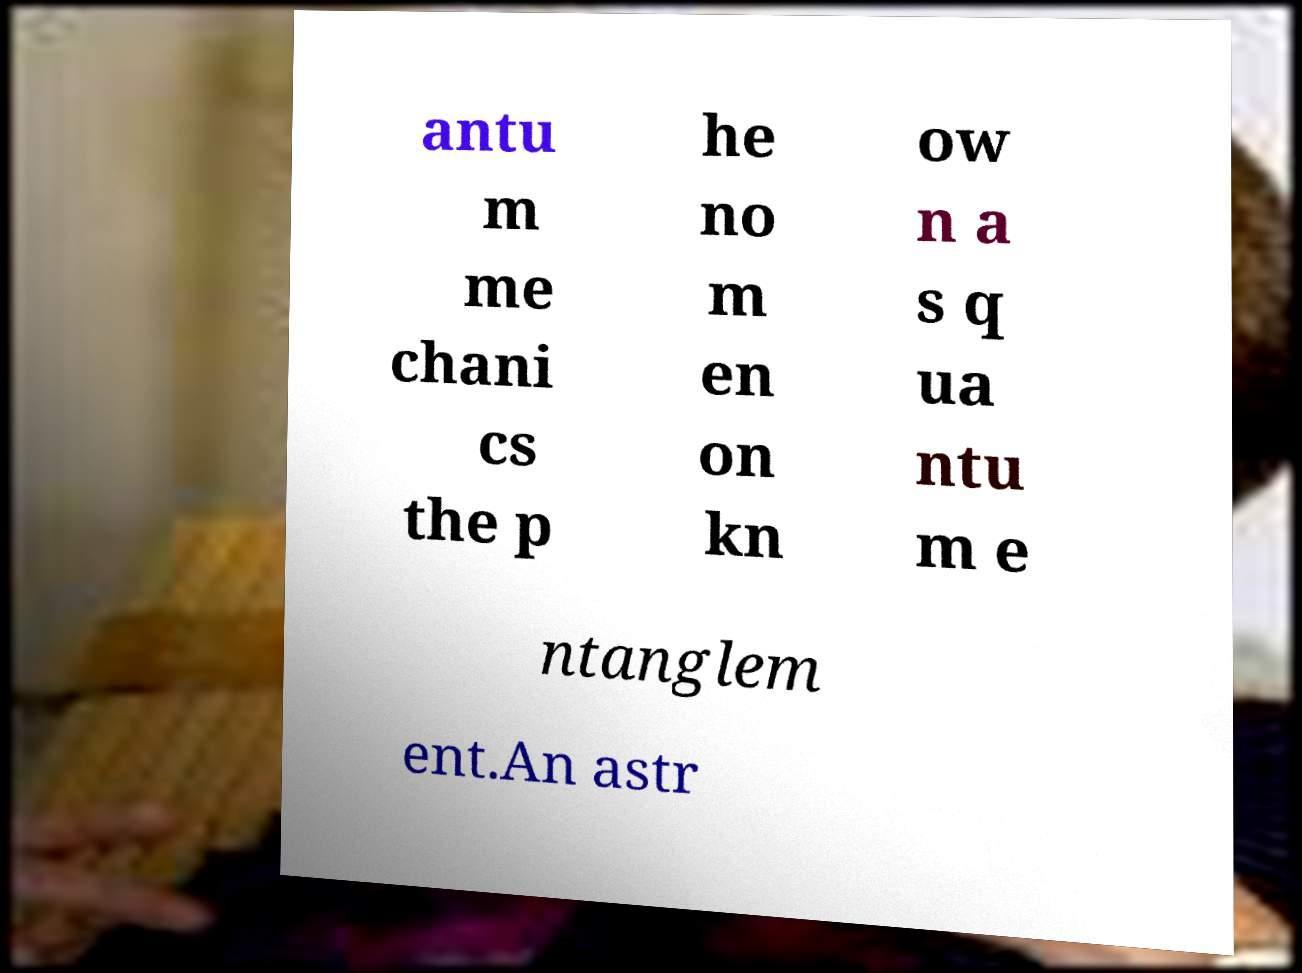What messages or text are displayed in this image? I need them in a readable, typed format. antu m me chani cs the p he no m en on kn ow n a s q ua ntu m e ntanglem ent.An astr 